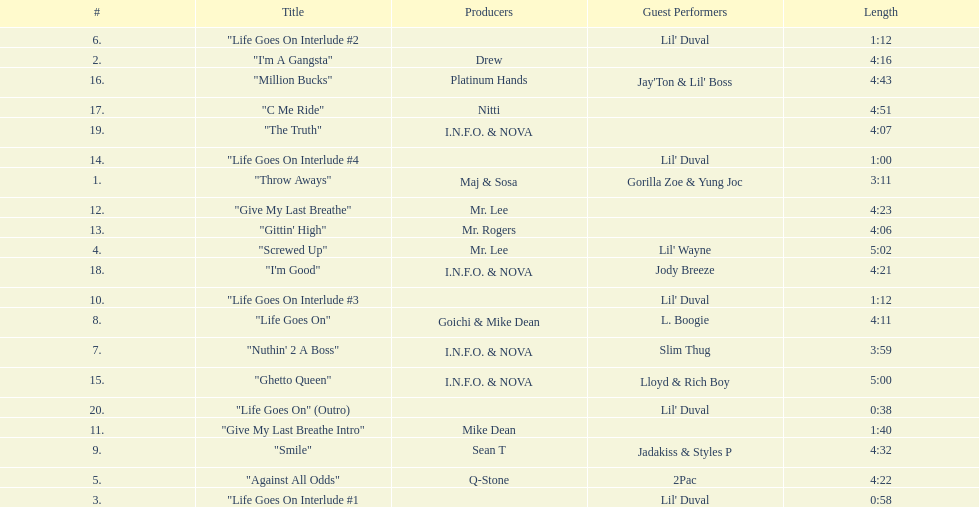Which tracks feature the same producer(s) in consecutive order on this album? "I'm Good", "The Truth". 